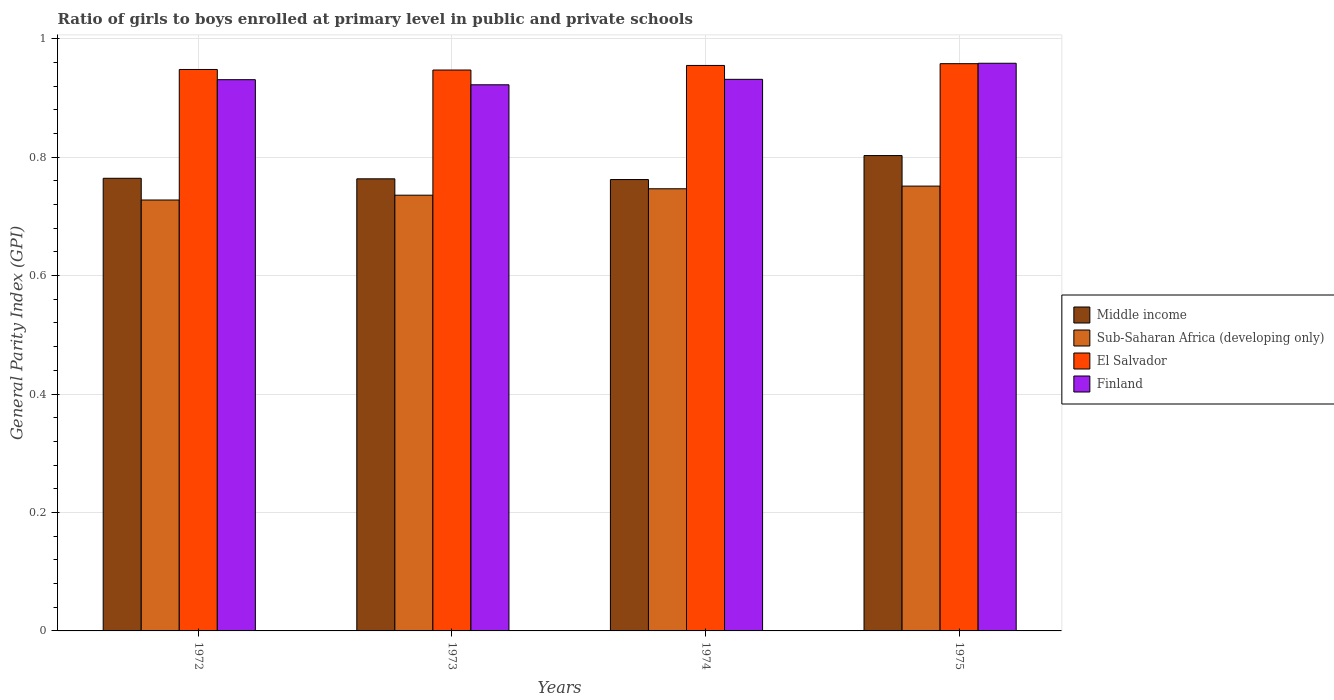How many different coloured bars are there?
Offer a terse response. 4. How many groups of bars are there?
Provide a short and direct response. 4. Are the number of bars per tick equal to the number of legend labels?
Provide a succinct answer. Yes. Are the number of bars on each tick of the X-axis equal?
Provide a short and direct response. Yes. How many bars are there on the 2nd tick from the left?
Give a very brief answer. 4. How many bars are there on the 1st tick from the right?
Provide a short and direct response. 4. What is the general parity index in Sub-Saharan Africa (developing only) in 1974?
Ensure brevity in your answer.  0.75. Across all years, what is the maximum general parity index in Middle income?
Make the answer very short. 0.8. Across all years, what is the minimum general parity index in Sub-Saharan Africa (developing only)?
Provide a short and direct response. 0.73. In which year was the general parity index in Finland maximum?
Give a very brief answer. 1975. In which year was the general parity index in Middle income minimum?
Your answer should be compact. 1974. What is the total general parity index in Finland in the graph?
Offer a terse response. 3.74. What is the difference between the general parity index in Middle income in 1973 and that in 1975?
Your answer should be compact. -0.04. What is the difference between the general parity index in Sub-Saharan Africa (developing only) in 1974 and the general parity index in El Salvador in 1972?
Offer a terse response. -0.2. What is the average general parity index in Middle income per year?
Make the answer very short. 0.77. In the year 1974, what is the difference between the general parity index in Sub-Saharan Africa (developing only) and general parity index in Middle income?
Ensure brevity in your answer.  -0.02. What is the ratio of the general parity index in Middle income in 1972 to that in 1974?
Your answer should be very brief. 1. Is the general parity index in Finland in 1973 less than that in 1974?
Provide a short and direct response. Yes. What is the difference between the highest and the second highest general parity index in Sub-Saharan Africa (developing only)?
Offer a terse response. 0. What is the difference between the highest and the lowest general parity index in Middle income?
Give a very brief answer. 0.04. Is the sum of the general parity index in El Salvador in 1973 and 1974 greater than the maximum general parity index in Sub-Saharan Africa (developing only) across all years?
Offer a very short reply. Yes. What does the 1st bar from the left in 1972 represents?
Your response must be concise. Middle income. How many bars are there?
Your response must be concise. 16. Where does the legend appear in the graph?
Provide a succinct answer. Center right. How many legend labels are there?
Provide a succinct answer. 4. How are the legend labels stacked?
Ensure brevity in your answer.  Vertical. What is the title of the graph?
Ensure brevity in your answer.  Ratio of girls to boys enrolled at primary level in public and private schools. What is the label or title of the Y-axis?
Offer a terse response. General Parity Index (GPI). What is the General Parity Index (GPI) of Middle income in 1972?
Give a very brief answer. 0.76. What is the General Parity Index (GPI) of Sub-Saharan Africa (developing only) in 1972?
Your response must be concise. 0.73. What is the General Parity Index (GPI) in El Salvador in 1972?
Give a very brief answer. 0.95. What is the General Parity Index (GPI) in Finland in 1972?
Your answer should be compact. 0.93. What is the General Parity Index (GPI) of Middle income in 1973?
Provide a short and direct response. 0.76. What is the General Parity Index (GPI) of Sub-Saharan Africa (developing only) in 1973?
Your answer should be very brief. 0.74. What is the General Parity Index (GPI) of El Salvador in 1973?
Offer a very short reply. 0.95. What is the General Parity Index (GPI) of Finland in 1973?
Your response must be concise. 0.92. What is the General Parity Index (GPI) in Middle income in 1974?
Provide a succinct answer. 0.76. What is the General Parity Index (GPI) of Sub-Saharan Africa (developing only) in 1974?
Your answer should be compact. 0.75. What is the General Parity Index (GPI) in El Salvador in 1974?
Your answer should be compact. 0.95. What is the General Parity Index (GPI) of Finland in 1974?
Keep it short and to the point. 0.93. What is the General Parity Index (GPI) in Middle income in 1975?
Give a very brief answer. 0.8. What is the General Parity Index (GPI) in Sub-Saharan Africa (developing only) in 1975?
Your answer should be compact. 0.75. What is the General Parity Index (GPI) in El Salvador in 1975?
Give a very brief answer. 0.96. What is the General Parity Index (GPI) of Finland in 1975?
Your answer should be compact. 0.96. Across all years, what is the maximum General Parity Index (GPI) of Middle income?
Keep it short and to the point. 0.8. Across all years, what is the maximum General Parity Index (GPI) of Sub-Saharan Africa (developing only)?
Offer a very short reply. 0.75. Across all years, what is the maximum General Parity Index (GPI) in El Salvador?
Your answer should be compact. 0.96. Across all years, what is the maximum General Parity Index (GPI) of Finland?
Provide a short and direct response. 0.96. Across all years, what is the minimum General Parity Index (GPI) of Middle income?
Ensure brevity in your answer.  0.76. Across all years, what is the minimum General Parity Index (GPI) in Sub-Saharan Africa (developing only)?
Offer a terse response. 0.73. Across all years, what is the minimum General Parity Index (GPI) of El Salvador?
Your response must be concise. 0.95. Across all years, what is the minimum General Parity Index (GPI) of Finland?
Offer a terse response. 0.92. What is the total General Parity Index (GPI) of Middle income in the graph?
Keep it short and to the point. 3.09. What is the total General Parity Index (GPI) of Sub-Saharan Africa (developing only) in the graph?
Provide a succinct answer. 2.96. What is the total General Parity Index (GPI) in El Salvador in the graph?
Your answer should be compact. 3.81. What is the total General Parity Index (GPI) of Finland in the graph?
Provide a succinct answer. 3.74. What is the difference between the General Parity Index (GPI) of Middle income in 1972 and that in 1973?
Offer a very short reply. 0. What is the difference between the General Parity Index (GPI) of Sub-Saharan Africa (developing only) in 1972 and that in 1973?
Make the answer very short. -0.01. What is the difference between the General Parity Index (GPI) in El Salvador in 1972 and that in 1973?
Offer a very short reply. 0. What is the difference between the General Parity Index (GPI) in Finland in 1972 and that in 1973?
Your answer should be very brief. 0.01. What is the difference between the General Parity Index (GPI) of Middle income in 1972 and that in 1974?
Your answer should be compact. 0. What is the difference between the General Parity Index (GPI) in Sub-Saharan Africa (developing only) in 1972 and that in 1974?
Your answer should be compact. -0.02. What is the difference between the General Parity Index (GPI) in El Salvador in 1972 and that in 1974?
Keep it short and to the point. -0.01. What is the difference between the General Parity Index (GPI) in Finland in 1972 and that in 1974?
Give a very brief answer. -0. What is the difference between the General Parity Index (GPI) in Middle income in 1972 and that in 1975?
Keep it short and to the point. -0.04. What is the difference between the General Parity Index (GPI) of Sub-Saharan Africa (developing only) in 1972 and that in 1975?
Offer a terse response. -0.02. What is the difference between the General Parity Index (GPI) of El Salvador in 1972 and that in 1975?
Provide a succinct answer. -0.01. What is the difference between the General Parity Index (GPI) in Finland in 1972 and that in 1975?
Offer a terse response. -0.03. What is the difference between the General Parity Index (GPI) in Middle income in 1973 and that in 1974?
Make the answer very short. 0. What is the difference between the General Parity Index (GPI) in Sub-Saharan Africa (developing only) in 1973 and that in 1974?
Give a very brief answer. -0.01. What is the difference between the General Parity Index (GPI) of El Salvador in 1973 and that in 1974?
Keep it short and to the point. -0.01. What is the difference between the General Parity Index (GPI) of Finland in 1973 and that in 1974?
Ensure brevity in your answer.  -0.01. What is the difference between the General Parity Index (GPI) in Middle income in 1973 and that in 1975?
Your response must be concise. -0.04. What is the difference between the General Parity Index (GPI) in Sub-Saharan Africa (developing only) in 1973 and that in 1975?
Your answer should be compact. -0.02. What is the difference between the General Parity Index (GPI) of El Salvador in 1973 and that in 1975?
Make the answer very short. -0.01. What is the difference between the General Parity Index (GPI) in Finland in 1973 and that in 1975?
Offer a terse response. -0.04. What is the difference between the General Parity Index (GPI) of Middle income in 1974 and that in 1975?
Provide a short and direct response. -0.04. What is the difference between the General Parity Index (GPI) of Sub-Saharan Africa (developing only) in 1974 and that in 1975?
Your response must be concise. -0. What is the difference between the General Parity Index (GPI) in El Salvador in 1974 and that in 1975?
Provide a succinct answer. -0. What is the difference between the General Parity Index (GPI) of Finland in 1974 and that in 1975?
Offer a terse response. -0.03. What is the difference between the General Parity Index (GPI) in Middle income in 1972 and the General Parity Index (GPI) in Sub-Saharan Africa (developing only) in 1973?
Provide a short and direct response. 0.03. What is the difference between the General Parity Index (GPI) in Middle income in 1972 and the General Parity Index (GPI) in El Salvador in 1973?
Make the answer very short. -0.18. What is the difference between the General Parity Index (GPI) in Middle income in 1972 and the General Parity Index (GPI) in Finland in 1973?
Offer a very short reply. -0.16. What is the difference between the General Parity Index (GPI) in Sub-Saharan Africa (developing only) in 1972 and the General Parity Index (GPI) in El Salvador in 1973?
Provide a succinct answer. -0.22. What is the difference between the General Parity Index (GPI) of Sub-Saharan Africa (developing only) in 1972 and the General Parity Index (GPI) of Finland in 1973?
Make the answer very short. -0.19. What is the difference between the General Parity Index (GPI) of El Salvador in 1972 and the General Parity Index (GPI) of Finland in 1973?
Provide a short and direct response. 0.03. What is the difference between the General Parity Index (GPI) in Middle income in 1972 and the General Parity Index (GPI) in Sub-Saharan Africa (developing only) in 1974?
Your response must be concise. 0.02. What is the difference between the General Parity Index (GPI) of Middle income in 1972 and the General Parity Index (GPI) of El Salvador in 1974?
Your answer should be compact. -0.19. What is the difference between the General Parity Index (GPI) in Middle income in 1972 and the General Parity Index (GPI) in Finland in 1974?
Your answer should be compact. -0.17. What is the difference between the General Parity Index (GPI) in Sub-Saharan Africa (developing only) in 1972 and the General Parity Index (GPI) in El Salvador in 1974?
Provide a succinct answer. -0.23. What is the difference between the General Parity Index (GPI) of Sub-Saharan Africa (developing only) in 1972 and the General Parity Index (GPI) of Finland in 1974?
Your answer should be very brief. -0.2. What is the difference between the General Parity Index (GPI) of El Salvador in 1972 and the General Parity Index (GPI) of Finland in 1974?
Ensure brevity in your answer.  0.02. What is the difference between the General Parity Index (GPI) in Middle income in 1972 and the General Parity Index (GPI) in Sub-Saharan Africa (developing only) in 1975?
Your answer should be very brief. 0.01. What is the difference between the General Parity Index (GPI) of Middle income in 1972 and the General Parity Index (GPI) of El Salvador in 1975?
Keep it short and to the point. -0.19. What is the difference between the General Parity Index (GPI) in Middle income in 1972 and the General Parity Index (GPI) in Finland in 1975?
Provide a short and direct response. -0.19. What is the difference between the General Parity Index (GPI) in Sub-Saharan Africa (developing only) in 1972 and the General Parity Index (GPI) in El Salvador in 1975?
Your answer should be compact. -0.23. What is the difference between the General Parity Index (GPI) in Sub-Saharan Africa (developing only) in 1972 and the General Parity Index (GPI) in Finland in 1975?
Provide a succinct answer. -0.23. What is the difference between the General Parity Index (GPI) of El Salvador in 1972 and the General Parity Index (GPI) of Finland in 1975?
Your answer should be compact. -0.01. What is the difference between the General Parity Index (GPI) in Middle income in 1973 and the General Parity Index (GPI) in Sub-Saharan Africa (developing only) in 1974?
Your response must be concise. 0.02. What is the difference between the General Parity Index (GPI) of Middle income in 1973 and the General Parity Index (GPI) of El Salvador in 1974?
Your answer should be very brief. -0.19. What is the difference between the General Parity Index (GPI) in Middle income in 1973 and the General Parity Index (GPI) in Finland in 1974?
Ensure brevity in your answer.  -0.17. What is the difference between the General Parity Index (GPI) of Sub-Saharan Africa (developing only) in 1973 and the General Parity Index (GPI) of El Salvador in 1974?
Offer a very short reply. -0.22. What is the difference between the General Parity Index (GPI) in Sub-Saharan Africa (developing only) in 1973 and the General Parity Index (GPI) in Finland in 1974?
Provide a short and direct response. -0.2. What is the difference between the General Parity Index (GPI) in El Salvador in 1973 and the General Parity Index (GPI) in Finland in 1974?
Ensure brevity in your answer.  0.02. What is the difference between the General Parity Index (GPI) in Middle income in 1973 and the General Parity Index (GPI) in Sub-Saharan Africa (developing only) in 1975?
Give a very brief answer. 0.01. What is the difference between the General Parity Index (GPI) in Middle income in 1973 and the General Parity Index (GPI) in El Salvador in 1975?
Your response must be concise. -0.19. What is the difference between the General Parity Index (GPI) of Middle income in 1973 and the General Parity Index (GPI) of Finland in 1975?
Provide a short and direct response. -0.2. What is the difference between the General Parity Index (GPI) in Sub-Saharan Africa (developing only) in 1973 and the General Parity Index (GPI) in El Salvador in 1975?
Make the answer very short. -0.22. What is the difference between the General Parity Index (GPI) of Sub-Saharan Africa (developing only) in 1973 and the General Parity Index (GPI) of Finland in 1975?
Offer a terse response. -0.22. What is the difference between the General Parity Index (GPI) in El Salvador in 1973 and the General Parity Index (GPI) in Finland in 1975?
Your response must be concise. -0.01. What is the difference between the General Parity Index (GPI) in Middle income in 1974 and the General Parity Index (GPI) in Sub-Saharan Africa (developing only) in 1975?
Your response must be concise. 0.01. What is the difference between the General Parity Index (GPI) of Middle income in 1974 and the General Parity Index (GPI) of El Salvador in 1975?
Offer a very short reply. -0.2. What is the difference between the General Parity Index (GPI) in Middle income in 1974 and the General Parity Index (GPI) in Finland in 1975?
Offer a terse response. -0.2. What is the difference between the General Parity Index (GPI) in Sub-Saharan Africa (developing only) in 1974 and the General Parity Index (GPI) in El Salvador in 1975?
Offer a terse response. -0.21. What is the difference between the General Parity Index (GPI) in Sub-Saharan Africa (developing only) in 1974 and the General Parity Index (GPI) in Finland in 1975?
Your answer should be compact. -0.21. What is the difference between the General Parity Index (GPI) of El Salvador in 1974 and the General Parity Index (GPI) of Finland in 1975?
Give a very brief answer. -0. What is the average General Parity Index (GPI) in Middle income per year?
Give a very brief answer. 0.77. What is the average General Parity Index (GPI) of Sub-Saharan Africa (developing only) per year?
Your response must be concise. 0.74. What is the average General Parity Index (GPI) in El Salvador per year?
Provide a succinct answer. 0.95. What is the average General Parity Index (GPI) of Finland per year?
Provide a short and direct response. 0.94. In the year 1972, what is the difference between the General Parity Index (GPI) of Middle income and General Parity Index (GPI) of Sub-Saharan Africa (developing only)?
Your answer should be compact. 0.04. In the year 1972, what is the difference between the General Parity Index (GPI) in Middle income and General Parity Index (GPI) in El Salvador?
Make the answer very short. -0.18. In the year 1972, what is the difference between the General Parity Index (GPI) in Middle income and General Parity Index (GPI) in Finland?
Provide a succinct answer. -0.17. In the year 1972, what is the difference between the General Parity Index (GPI) of Sub-Saharan Africa (developing only) and General Parity Index (GPI) of El Salvador?
Make the answer very short. -0.22. In the year 1972, what is the difference between the General Parity Index (GPI) in Sub-Saharan Africa (developing only) and General Parity Index (GPI) in Finland?
Your response must be concise. -0.2. In the year 1972, what is the difference between the General Parity Index (GPI) of El Salvador and General Parity Index (GPI) of Finland?
Your response must be concise. 0.02. In the year 1973, what is the difference between the General Parity Index (GPI) of Middle income and General Parity Index (GPI) of Sub-Saharan Africa (developing only)?
Your response must be concise. 0.03. In the year 1973, what is the difference between the General Parity Index (GPI) of Middle income and General Parity Index (GPI) of El Salvador?
Your answer should be compact. -0.18. In the year 1973, what is the difference between the General Parity Index (GPI) in Middle income and General Parity Index (GPI) in Finland?
Provide a succinct answer. -0.16. In the year 1973, what is the difference between the General Parity Index (GPI) of Sub-Saharan Africa (developing only) and General Parity Index (GPI) of El Salvador?
Offer a very short reply. -0.21. In the year 1973, what is the difference between the General Parity Index (GPI) in Sub-Saharan Africa (developing only) and General Parity Index (GPI) in Finland?
Ensure brevity in your answer.  -0.19. In the year 1973, what is the difference between the General Parity Index (GPI) of El Salvador and General Parity Index (GPI) of Finland?
Offer a terse response. 0.02. In the year 1974, what is the difference between the General Parity Index (GPI) in Middle income and General Parity Index (GPI) in Sub-Saharan Africa (developing only)?
Give a very brief answer. 0.02. In the year 1974, what is the difference between the General Parity Index (GPI) of Middle income and General Parity Index (GPI) of El Salvador?
Ensure brevity in your answer.  -0.19. In the year 1974, what is the difference between the General Parity Index (GPI) of Middle income and General Parity Index (GPI) of Finland?
Give a very brief answer. -0.17. In the year 1974, what is the difference between the General Parity Index (GPI) in Sub-Saharan Africa (developing only) and General Parity Index (GPI) in El Salvador?
Give a very brief answer. -0.21. In the year 1974, what is the difference between the General Parity Index (GPI) of Sub-Saharan Africa (developing only) and General Parity Index (GPI) of Finland?
Make the answer very short. -0.18. In the year 1974, what is the difference between the General Parity Index (GPI) of El Salvador and General Parity Index (GPI) of Finland?
Give a very brief answer. 0.02. In the year 1975, what is the difference between the General Parity Index (GPI) in Middle income and General Parity Index (GPI) in Sub-Saharan Africa (developing only)?
Give a very brief answer. 0.05. In the year 1975, what is the difference between the General Parity Index (GPI) in Middle income and General Parity Index (GPI) in El Salvador?
Offer a very short reply. -0.16. In the year 1975, what is the difference between the General Parity Index (GPI) of Middle income and General Parity Index (GPI) of Finland?
Make the answer very short. -0.16. In the year 1975, what is the difference between the General Parity Index (GPI) of Sub-Saharan Africa (developing only) and General Parity Index (GPI) of El Salvador?
Your answer should be compact. -0.21. In the year 1975, what is the difference between the General Parity Index (GPI) in Sub-Saharan Africa (developing only) and General Parity Index (GPI) in Finland?
Your answer should be very brief. -0.21. In the year 1975, what is the difference between the General Parity Index (GPI) in El Salvador and General Parity Index (GPI) in Finland?
Offer a very short reply. -0. What is the ratio of the General Parity Index (GPI) of Sub-Saharan Africa (developing only) in 1972 to that in 1973?
Provide a succinct answer. 0.99. What is the ratio of the General Parity Index (GPI) in Finland in 1972 to that in 1973?
Make the answer very short. 1.01. What is the ratio of the General Parity Index (GPI) of Middle income in 1972 to that in 1974?
Your response must be concise. 1. What is the ratio of the General Parity Index (GPI) in Sub-Saharan Africa (developing only) in 1972 to that in 1974?
Give a very brief answer. 0.97. What is the ratio of the General Parity Index (GPI) in El Salvador in 1972 to that in 1974?
Offer a very short reply. 0.99. What is the ratio of the General Parity Index (GPI) of Middle income in 1972 to that in 1975?
Offer a terse response. 0.95. What is the ratio of the General Parity Index (GPI) of Sub-Saharan Africa (developing only) in 1972 to that in 1975?
Make the answer very short. 0.97. What is the ratio of the General Parity Index (GPI) in El Salvador in 1972 to that in 1975?
Your answer should be very brief. 0.99. What is the ratio of the General Parity Index (GPI) of Finland in 1972 to that in 1975?
Provide a succinct answer. 0.97. What is the ratio of the General Parity Index (GPI) of Sub-Saharan Africa (developing only) in 1973 to that in 1974?
Ensure brevity in your answer.  0.99. What is the ratio of the General Parity Index (GPI) of Finland in 1973 to that in 1974?
Ensure brevity in your answer.  0.99. What is the ratio of the General Parity Index (GPI) of Middle income in 1973 to that in 1975?
Give a very brief answer. 0.95. What is the ratio of the General Parity Index (GPI) in Sub-Saharan Africa (developing only) in 1973 to that in 1975?
Give a very brief answer. 0.98. What is the ratio of the General Parity Index (GPI) in El Salvador in 1973 to that in 1975?
Provide a short and direct response. 0.99. What is the ratio of the General Parity Index (GPI) in Finland in 1973 to that in 1975?
Your answer should be very brief. 0.96. What is the ratio of the General Parity Index (GPI) of Middle income in 1974 to that in 1975?
Make the answer very short. 0.95. What is the ratio of the General Parity Index (GPI) of Finland in 1974 to that in 1975?
Offer a terse response. 0.97. What is the difference between the highest and the second highest General Parity Index (GPI) in Middle income?
Your answer should be very brief. 0.04. What is the difference between the highest and the second highest General Parity Index (GPI) of Sub-Saharan Africa (developing only)?
Ensure brevity in your answer.  0. What is the difference between the highest and the second highest General Parity Index (GPI) in El Salvador?
Your answer should be very brief. 0. What is the difference between the highest and the second highest General Parity Index (GPI) of Finland?
Your answer should be very brief. 0.03. What is the difference between the highest and the lowest General Parity Index (GPI) in Middle income?
Offer a very short reply. 0.04. What is the difference between the highest and the lowest General Parity Index (GPI) of Sub-Saharan Africa (developing only)?
Offer a very short reply. 0.02. What is the difference between the highest and the lowest General Parity Index (GPI) in El Salvador?
Give a very brief answer. 0.01. What is the difference between the highest and the lowest General Parity Index (GPI) of Finland?
Your answer should be compact. 0.04. 